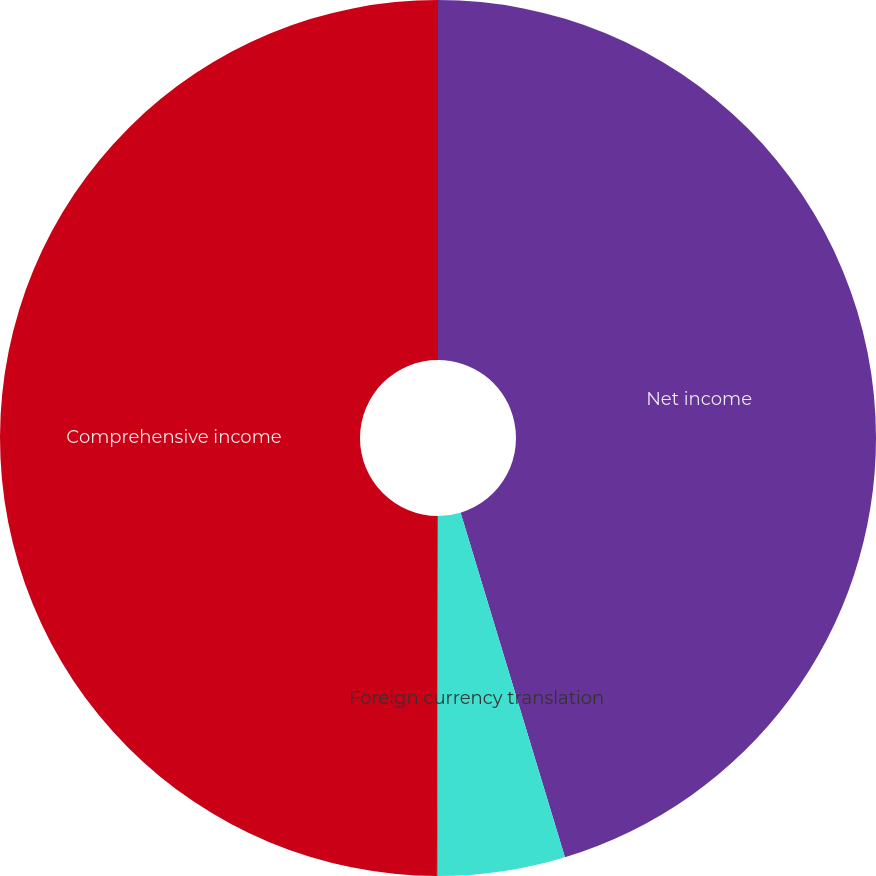<chart> <loc_0><loc_0><loc_500><loc_500><pie_chart><fcel>Net income<fcel>Foreign currency translation<fcel>Changes in unrealized holding<fcel>Comprehensive income<nl><fcel>45.32%<fcel>4.68%<fcel>0.04%<fcel>49.96%<nl></chart> 